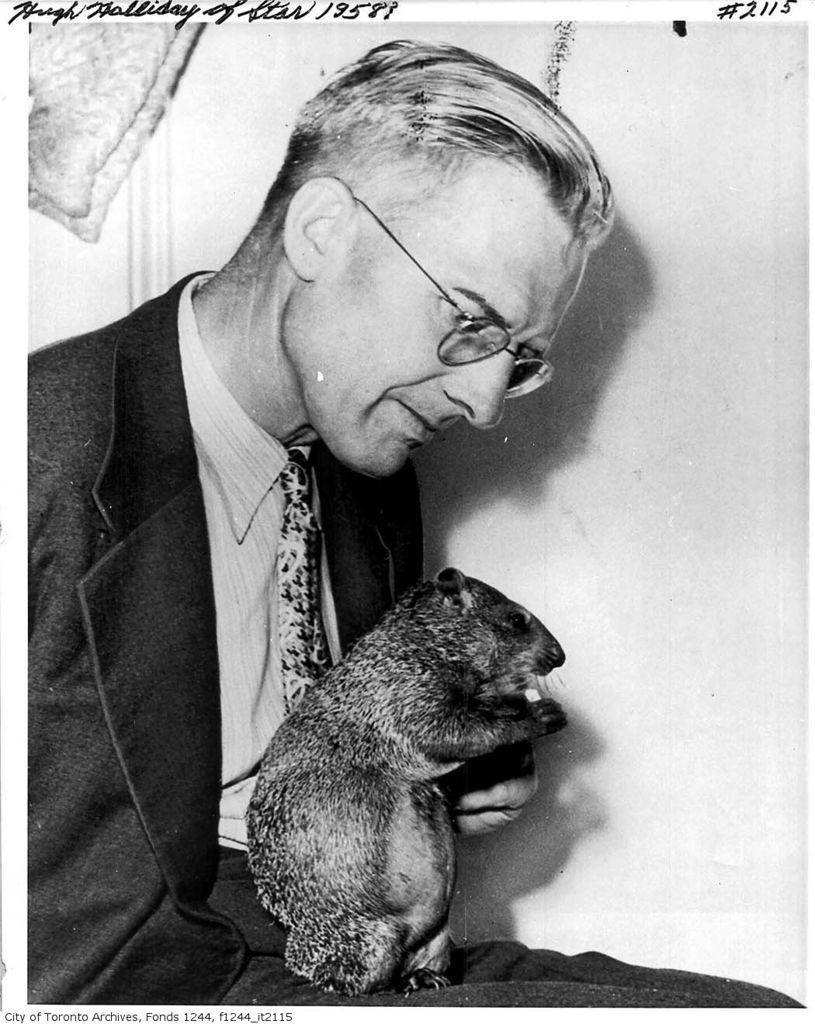Could you give a brief overview of what you see in this image? In this picture I can see there is a man sitting, he is wearing a blazer, shirt, a tie and spectacles. There is a rat on his leg and he is looking at it. In the backdrop I can see there is a wall and there is something written on the top of it. 